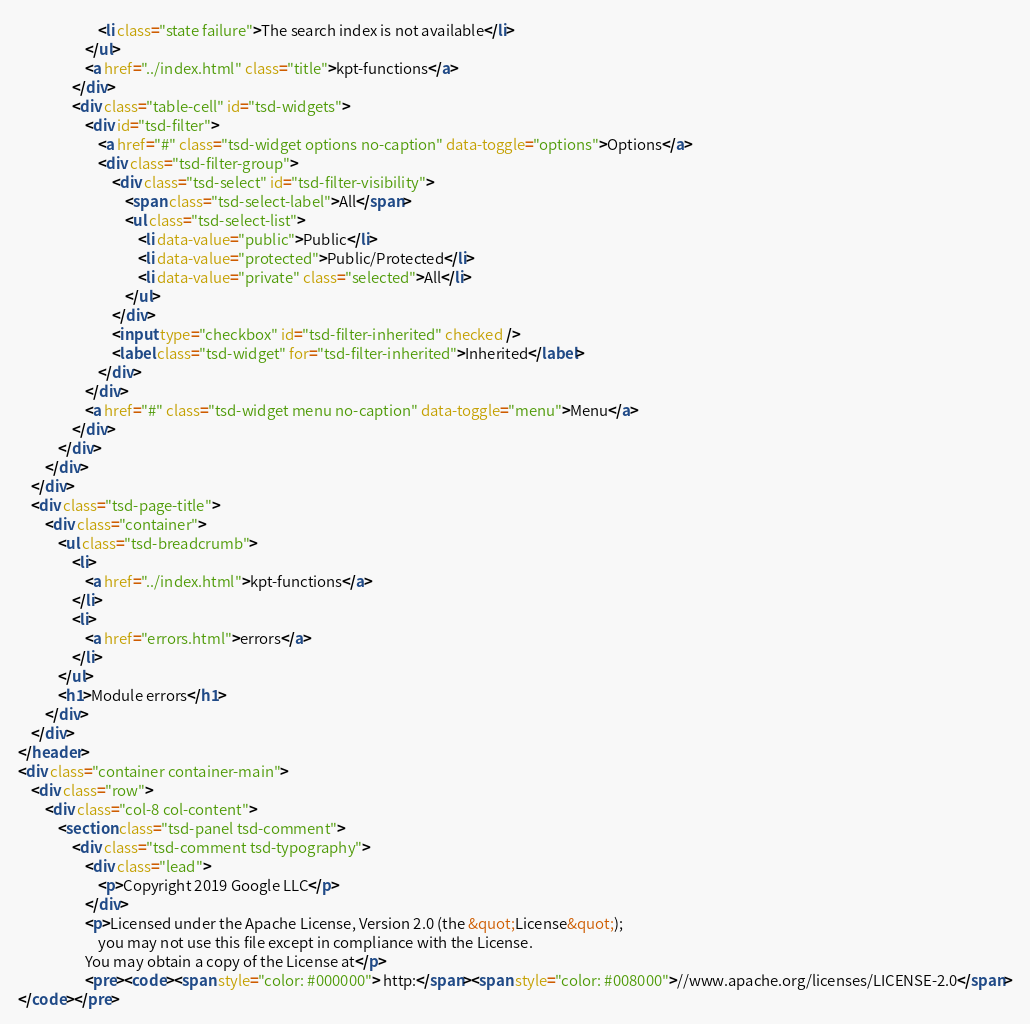<code> <loc_0><loc_0><loc_500><loc_500><_HTML_>						<li class="state failure">The search index is not available</li>
					</ul>
					<a href="../index.html" class="title">kpt-functions</a>
				</div>
				<div class="table-cell" id="tsd-widgets">
					<div id="tsd-filter">
						<a href="#" class="tsd-widget options no-caption" data-toggle="options">Options</a>
						<div class="tsd-filter-group">
							<div class="tsd-select" id="tsd-filter-visibility">
								<span class="tsd-select-label">All</span>
								<ul class="tsd-select-list">
									<li data-value="public">Public</li>
									<li data-value="protected">Public/Protected</li>
									<li data-value="private" class="selected">All</li>
								</ul>
							</div>
							<input type="checkbox" id="tsd-filter-inherited" checked />
							<label class="tsd-widget" for="tsd-filter-inherited">Inherited</label>
						</div>
					</div>
					<a href="#" class="tsd-widget menu no-caption" data-toggle="menu">Menu</a>
				</div>
			</div>
		</div>
	</div>
	<div class="tsd-page-title">
		<div class="container">
			<ul class="tsd-breadcrumb">
				<li>
					<a href="../index.html">kpt-functions</a>
				</li>
				<li>
					<a href="errors.html">errors</a>
				</li>
			</ul>
			<h1>Module errors</h1>
		</div>
	</div>
</header>
<div class="container container-main">
	<div class="row">
		<div class="col-8 col-content">
			<section class="tsd-panel tsd-comment">
				<div class="tsd-comment tsd-typography">
					<div class="lead">
						<p>Copyright 2019 Google LLC</p>
					</div>
					<p>Licensed under the Apache License, Version 2.0 (the &quot;License&quot;);
						you may not use this file except in compliance with the License.
					You may obtain a copy of the License at</p>
					<pre><code><span style="color: #000000"> http:</span><span style="color: #008000">//www.apache.org/licenses/LICENSE-2.0</span>
</code></pre></code> 